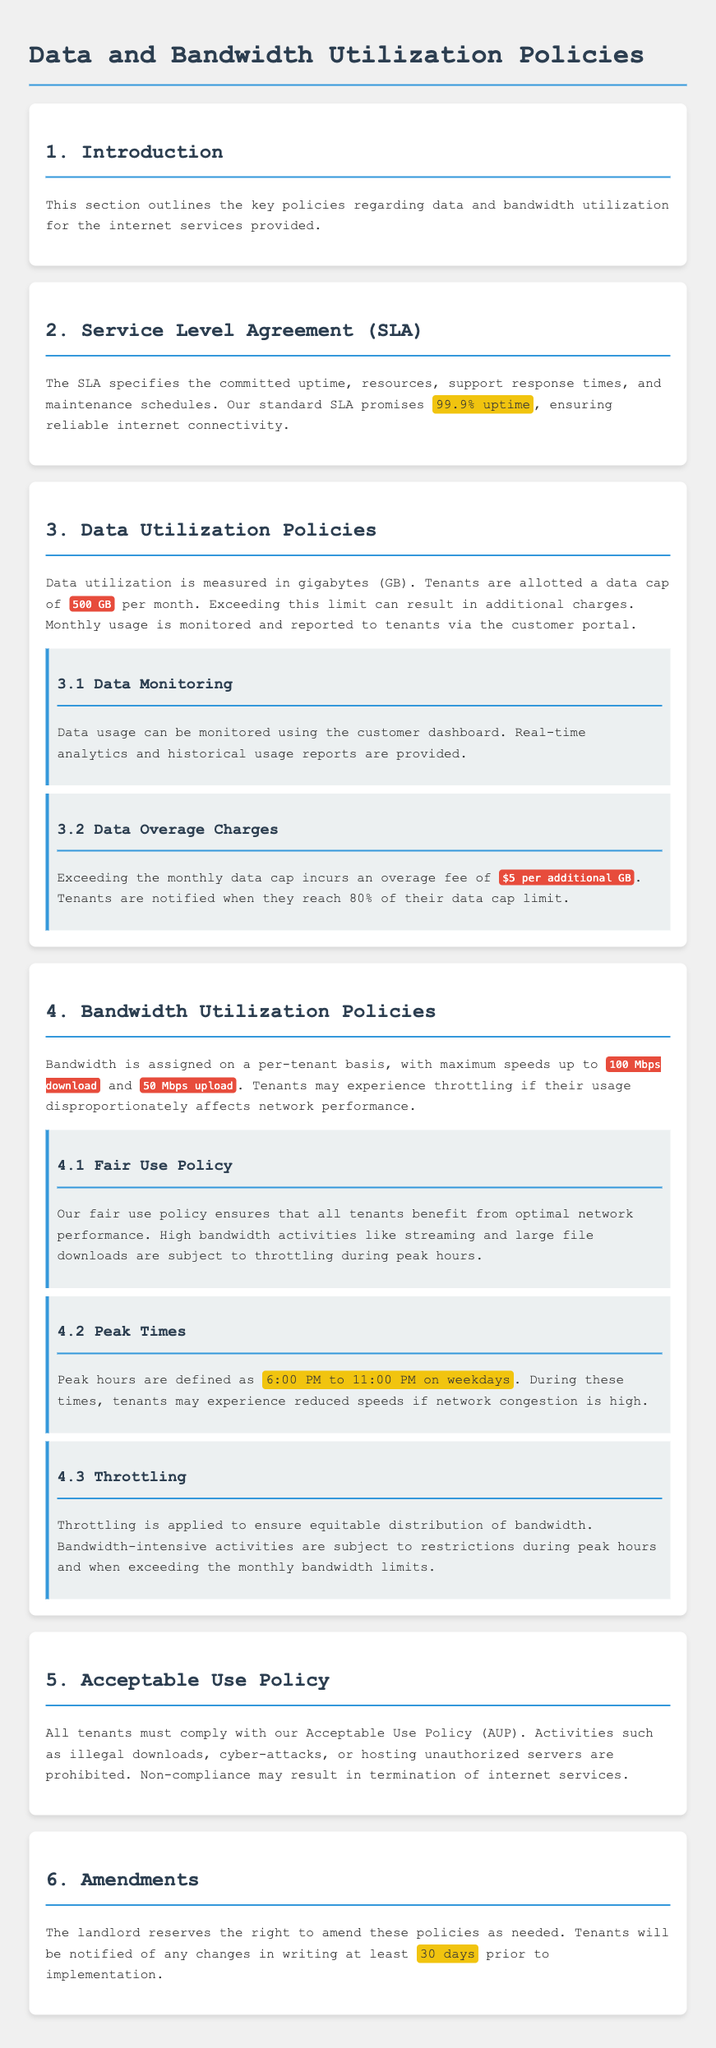What is the data cap per month? The document specifies that tenants are allotted a data cap of 500 GB per month.
Answer: 500 GB What is the overage fee per additional GB? The policy states that exceeding the monthly data cap incurs an overage fee of 5 dollars per additional GB.
Answer: 5 dollars What is the maximum download speed for bandwidth? According to the document, the maximum download speed assigned to each tenant is 100 Mbps.
Answer: 100 Mbps What time frame defines peak hours? The document defines peak hours as 6:00 PM to 11:00 PM on weekdays.
Answer: 6:00 PM to 11:00 PM What is the uptime commitment in the SLA? The SLA promises a committed uptime of 99.9%, ensuring reliable internet connectivity.
Answer: 99.9% What should tenants do if they exceed 80% of their data cap limit? The document states that tenants are notified when they reach 80% of their data cap limit.
Answer: notified What is the fair use policy designed to ensure? The fair use policy is designed to ensure that all tenants benefit from optimal network performance.
Answer: optimal network performance What may happen if tenants are non-compliant with the Acceptable Use Policy? Non-compliance with the Acceptable Use Policy may result in the termination of internet services.
Answer: termination What notice period is required for amendments to policies? The landlord must notify tenants of any changes in writing at least 30 days prior to implementation.
Answer: 30 days 